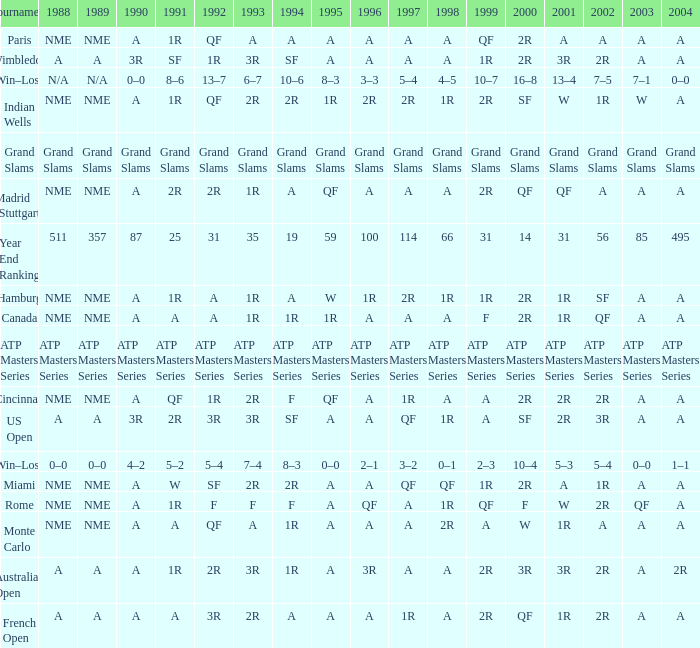What shows for 202 when the 1994 is A, the 1989 is NME, and the 199 is 2R? A. 